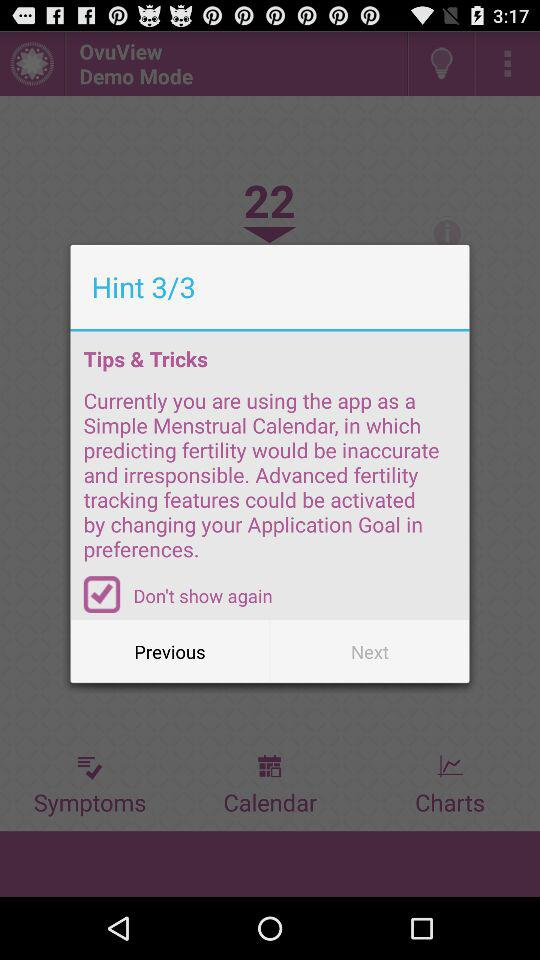How many hints are there? There are 3 hints. 